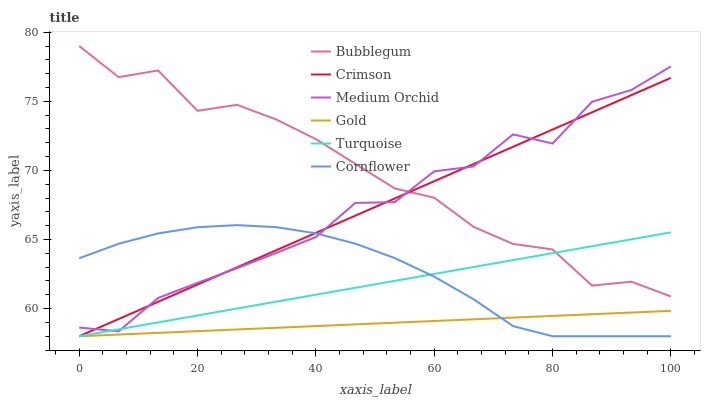Does Turquoise have the minimum area under the curve?
Answer yes or no. No. Does Turquoise have the maximum area under the curve?
Answer yes or no. No. Is Turquoise the smoothest?
Answer yes or no. No. Is Turquoise the roughest?
Answer yes or no. No. Does Medium Orchid have the lowest value?
Answer yes or no. No. Does Turquoise have the highest value?
Answer yes or no. No. Is Cornflower less than Bubblegum?
Answer yes or no. Yes. Is Bubblegum greater than Cornflower?
Answer yes or no. Yes. Does Cornflower intersect Bubblegum?
Answer yes or no. No. 